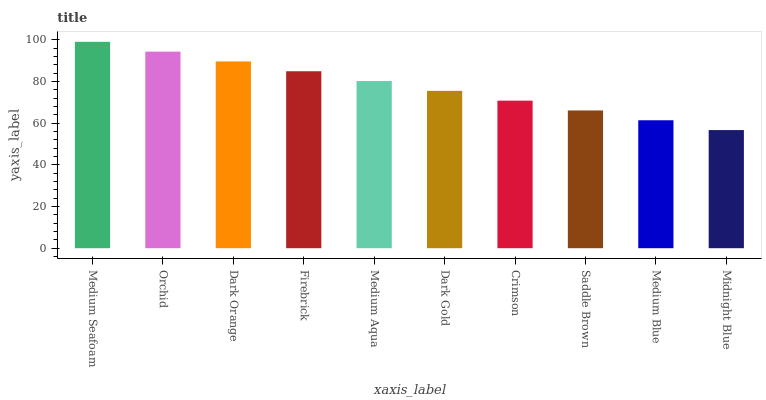Is Midnight Blue the minimum?
Answer yes or no. Yes. Is Medium Seafoam the maximum?
Answer yes or no. Yes. Is Orchid the minimum?
Answer yes or no. No. Is Orchid the maximum?
Answer yes or no. No. Is Medium Seafoam greater than Orchid?
Answer yes or no. Yes. Is Orchid less than Medium Seafoam?
Answer yes or no. Yes. Is Orchid greater than Medium Seafoam?
Answer yes or no. No. Is Medium Seafoam less than Orchid?
Answer yes or no. No. Is Medium Aqua the high median?
Answer yes or no. Yes. Is Dark Gold the low median?
Answer yes or no. Yes. Is Dark Orange the high median?
Answer yes or no. No. Is Medium Blue the low median?
Answer yes or no. No. 